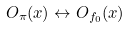Convert formula to latex. <formula><loc_0><loc_0><loc_500><loc_500>O _ { \pi } ( x ) \leftrightarrow O _ { f _ { 0 } } ( x )</formula> 